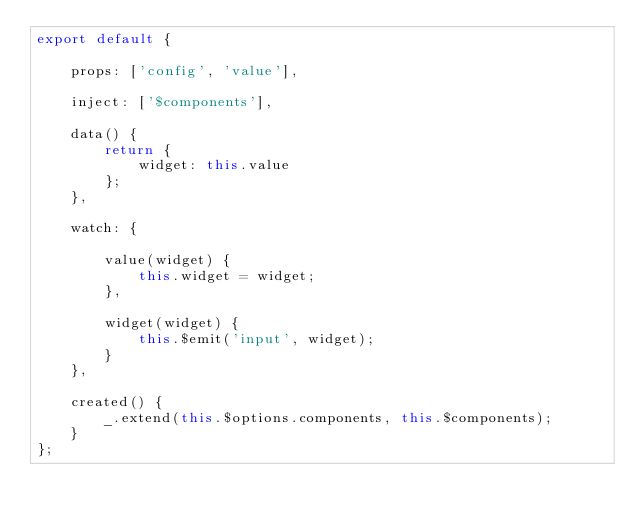<code> <loc_0><loc_0><loc_500><loc_500><_JavaScript_>export default {

    props: ['config', 'value'],

    inject: ['$components'],

    data() {
        return {
            widget: this.value
        };
    },

    watch: {

        value(widget) {
            this.widget = widget;
        },

        widget(widget) {
            this.$emit('input', widget);
        }
    },

    created() {
        _.extend(this.$options.components, this.$components);
    }
};
</code> 